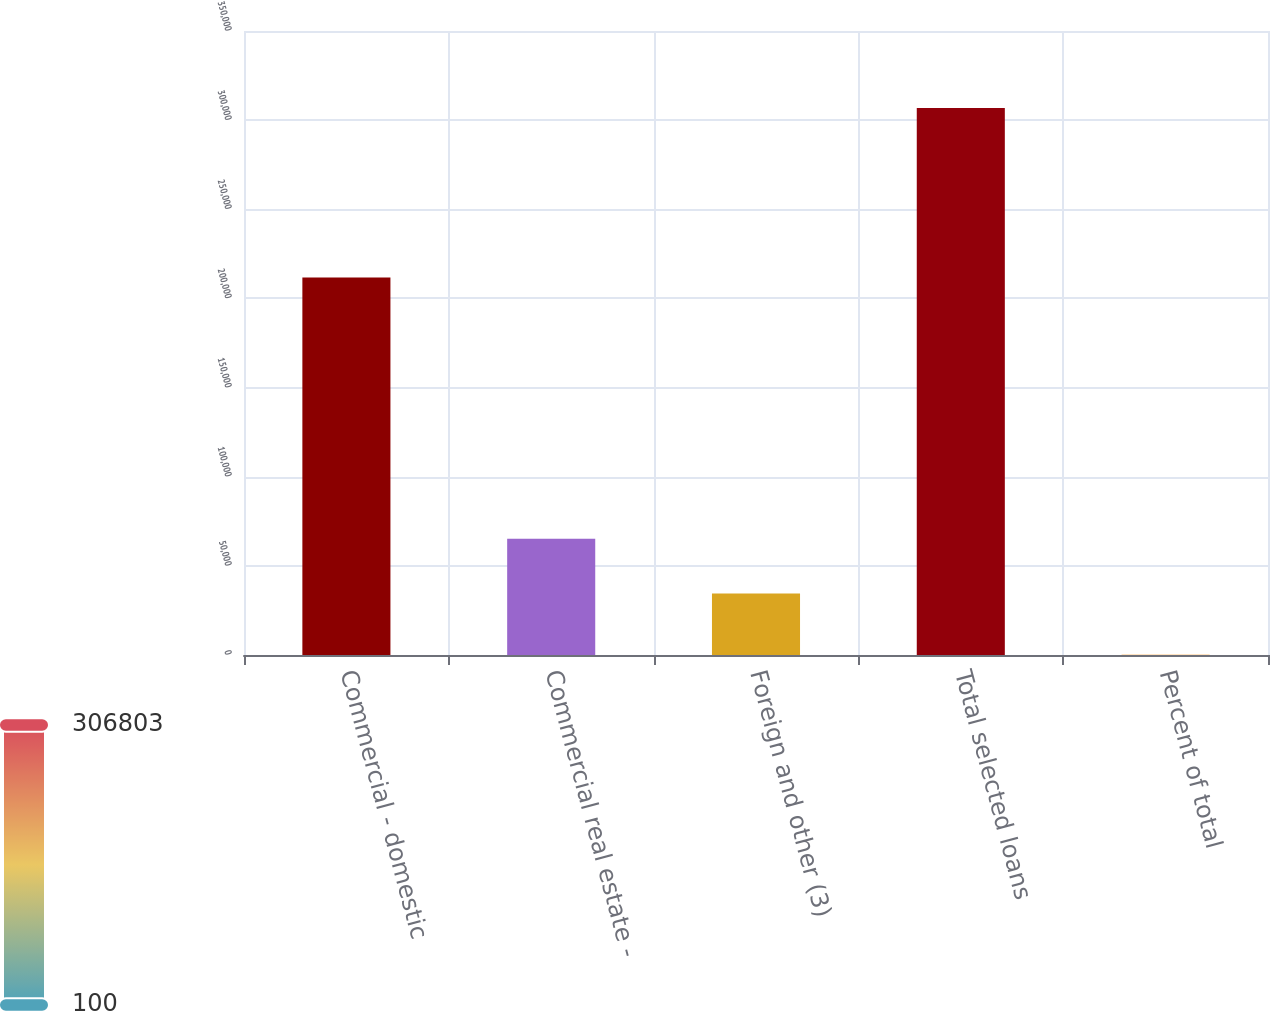<chart> <loc_0><loc_0><loc_500><loc_500><bar_chart><fcel>Commercial - domestic<fcel>Commercial real estate -<fcel>Foreign and other (3)<fcel>Total selected loans<fcel>Percent of total<nl><fcel>211792<fcel>65143.3<fcel>34473<fcel>306803<fcel>100<nl></chart> 